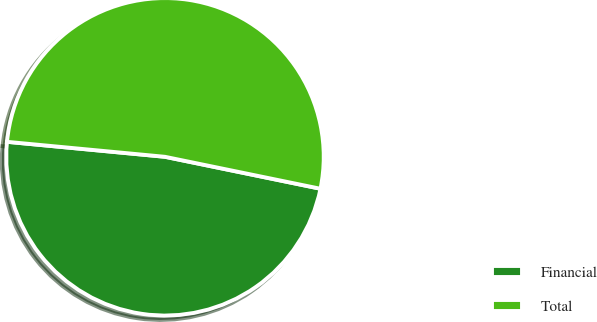Convert chart. <chart><loc_0><loc_0><loc_500><loc_500><pie_chart><fcel>Financial<fcel>Total<nl><fcel>48.28%<fcel>51.72%<nl></chart> 